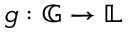<formula> <loc_0><loc_0><loc_500><loc_500>g \colon { \mathbb { G } } \rightarrow { \mathbb { L } }</formula> 